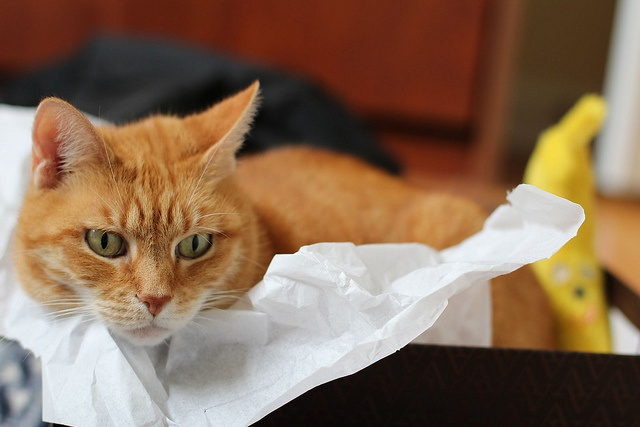Describe the objects in this image and their specific colors. I can see cat in maroon, brown, and tan tones and banana in maroon, olive, gold, and tan tones in this image. 